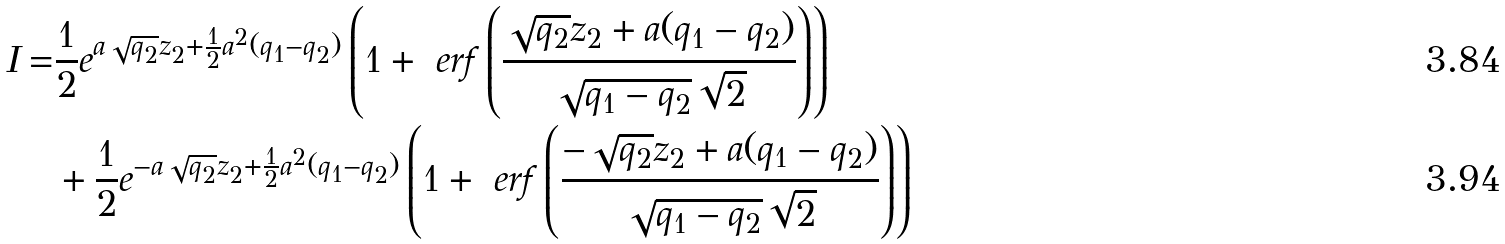<formula> <loc_0><loc_0><loc_500><loc_500>I = & \frac { 1 } { 2 } e ^ { a \sqrt { q _ { 2 } } z _ { 2 } + \frac { 1 } { 2 } a ^ { 2 } ( q _ { 1 } - q _ { 2 } ) } \left ( 1 + \ e r f \left ( \frac { \sqrt { q _ { 2 } } z _ { 2 } + a ( q _ { 1 } - q _ { 2 } ) } { \sqrt { q _ { 1 } - q _ { 2 } } \sqrt { 2 } } \right ) \right ) \\ & + \frac { 1 } { 2 } e ^ { - a \sqrt { q _ { 2 } } z _ { 2 } + \frac { 1 } { 2 } a ^ { 2 } ( q _ { 1 } - q _ { 2 } ) } \left ( 1 + \ e r f \left ( \frac { - \sqrt { q _ { 2 } } z _ { 2 } + a ( q _ { 1 } - q _ { 2 } ) } { \sqrt { q _ { 1 } - q _ { 2 } } \sqrt { 2 } } \right ) \right )</formula> 